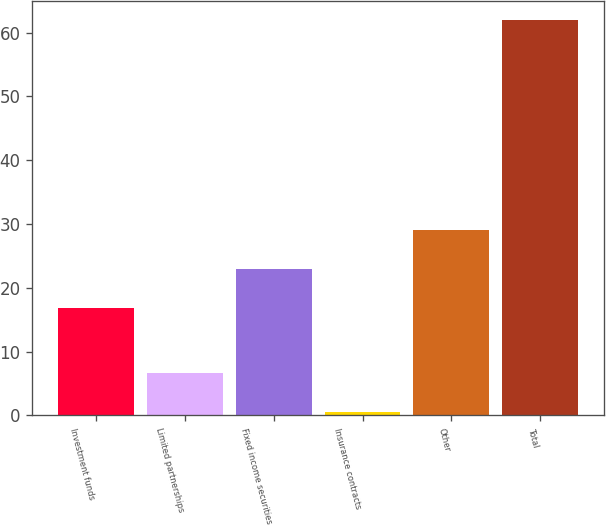Convert chart to OTSL. <chart><loc_0><loc_0><loc_500><loc_500><bar_chart><fcel>Investment funds<fcel>Limited partnerships<fcel>Fixed income securities<fcel>Insurance contracts<fcel>Other<fcel>Total<nl><fcel>16.8<fcel>6.59<fcel>22.95<fcel>0.45<fcel>29.09<fcel>61.9<nl></chart> 